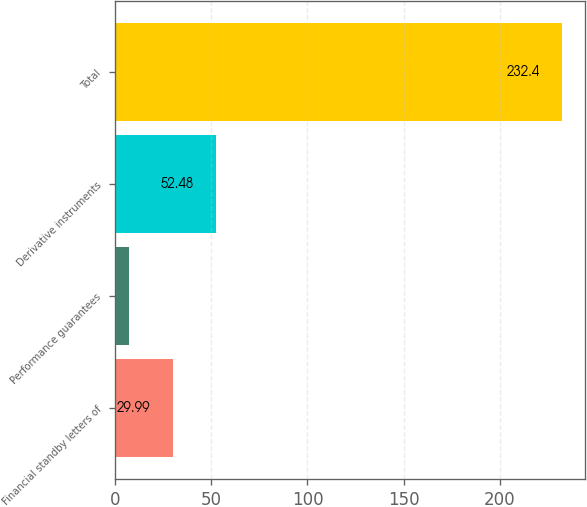Convert chart. <chart><loc_0><loc_0><loc_500><loc_500><bar_chart><fcel>Financial standby letters of<fcel>Performance guarantees<fcel>Derivative instruments<fcel>Total<nl><fcel>29.99<fcel>7.5<fcel>52.48<fcel>232.4<nl></chart> 